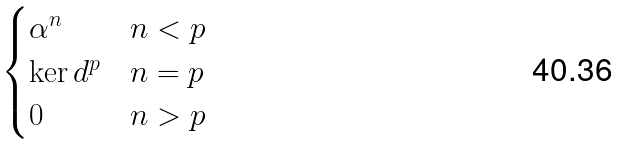Convert formula to latex. <formula><loc_0><loc_0><loc_500><loc_500>\begin{cases} \alpha ^ { n } & n < p \\ \ker d ^ { p } & n = p \\ 0 & n > p \end{cases}</formula> 